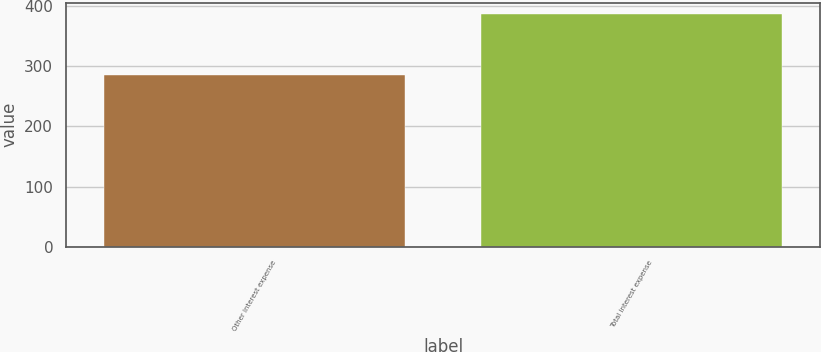Convert chart. <chart><loc_0><loc_0><loc_500><loc_500><bar_chart><fcel>Other interest expense<fcel>Total interest expense<nl><fcel>285<fcel>387<nl></chart> 